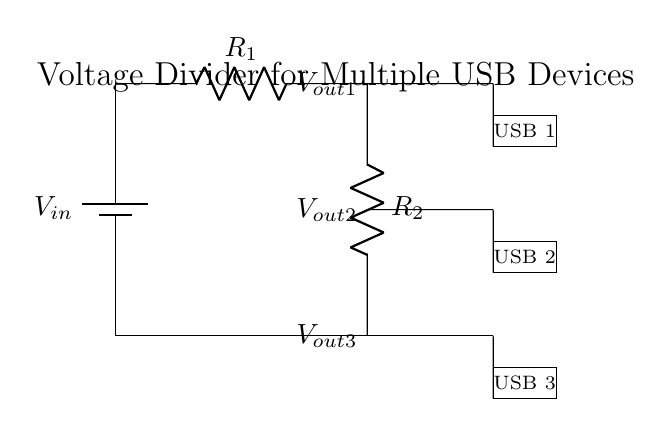What is the input voltage of the circuit? The input voltage, labeled as Vin, is the voltage supplied to the circuit from the battery, which is typically indicated on the diagram.
Answer: Vin How many USB outputs are there in this circuit? There are three USB outputs shown by three rectangles labeled as USB 1, USB 2, and USB 3, indicating that the circuit is designed to power three devices.
Answer: Three What are the resistors used in this circuit for? The resistors R1 and R2 are used for voltage division, which allows multiple outputs at different voltage levels from the same input voltage for powering USB devices.
Answer: Voltage division What are the output voltages labeled on the circuit? The circuit labels output voltages as Vout1, Vout2, and Vout3 at various points where USB devices connect, showing the distributed voltages for each respective output.
Answer: Vout1, Vout2, Vout3 If R1 is twice the value of R2, what will be the output voltage at USB 1? If R1 is twice R2, Vout1 can be calculated using the voltage divider rule (Vout = Vin * R2 / (R1 + R2)). Since R1 = 2R2, this simplifies to Vout1 = Vin / 3. Therefore, the output voltage is a third of the input voltage.
Answer: Vin/3 